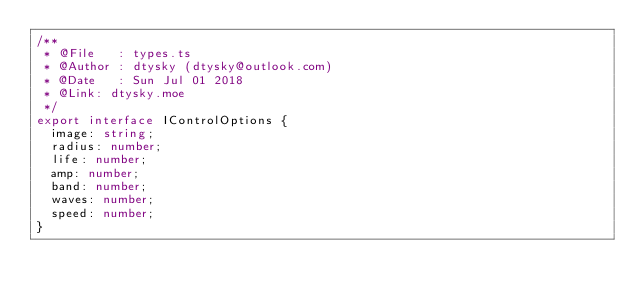Convert code to text. <code><loc_0><loc_0><loc_500><loc_500><_TypeScript_>/**
 * @File   : types.ts
 * @Author : dtysky (dtysky@outlook.com)
 * @Date   : Sun Jul 01 2018
 * @Link: dtysky.moe
 */
export interface IControlOptions {
  image: string;
  radius: number;
  life: number;
  amp: number;
  band: number;
  waves: number;
  speed: number;
}
</code> 